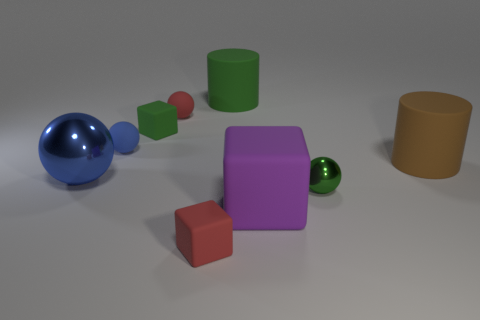What is the color of the other metal thing that is the same shape as the blue metallic thing?
Give a very brief answer. Green. There is a green block; is it the same size as the rubber thing right of the purple matte thing?
Your answer should be compact. No. What is the size of the green matte block?
Make the answer very short. Small. The other big cylinder that is the same material as the green cylinder is what color?
Offer a terse response. Brown. How many red objects are made of the same material as the large purple thing?
Provide a succinct answer. 2. How many things are big red matte balls or tiny spheres that are behind the big blue shiny object?
Give a very brief answer. 2. Are the tiny sphere to the right of the red rubber block and the tiny red sphere made of the same material?
Make the answer very short. No. The other cylinder that is the same size as the brown rubber cylinder is what color?
Give a very brief answer. Green. Is there a large green object that has the same shape as the large purple rubber object?
Your response must be concise. No. There is a tiny matte thing behind the tiny green thing left of the green thing behind the green matte block; what is its color?
Keep it short and to the point. Red. 